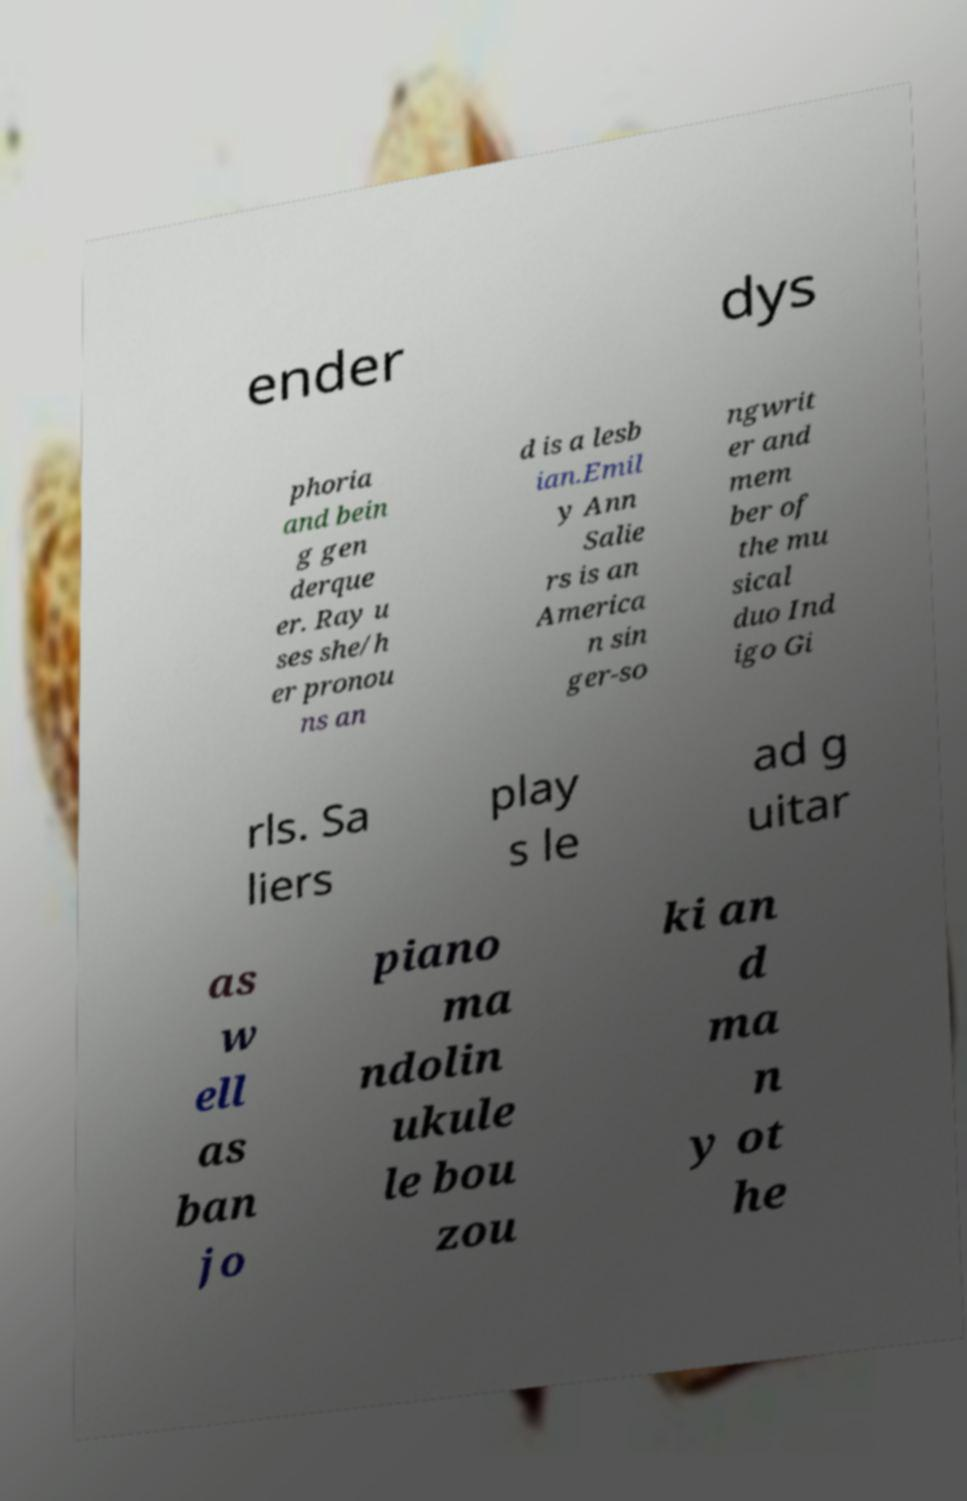Please read and relay the text visible in this image. What does it say? ender dys phoria and bein g gen derque er. Ray u ses she/h er pronou ns an d is a lesb ian.Emil y Ann Salie rs is an America n sin ger-so ngwrit er and mem ber of the mu sical duo Ind igo Gi rls. Sa liers play s le ad g uitar as w ell as ban jo piano ma ndolin ukule le bou zou ki an d ma n y ot he 